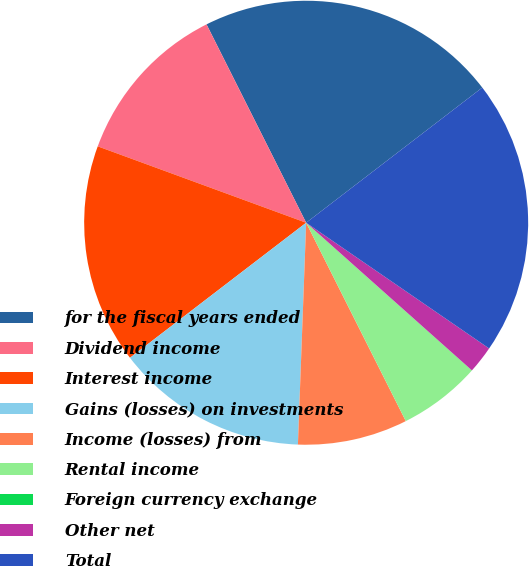Convert chart. <chart><loc_0><loc_0><loc_500><loc_500><pie_chart><fcel>for the fiscal years ended<fcel>Dividend income<fcel>Interest income<fcel>Gains (losses) on investments<fcel>Income (losses) from<fcel>Rental income<fcel>Foreign currency exchange<fcel>Other net<fcel>Total<nl><fcel>21.99%<fcel>12.0%<fcel>16.0%<fcel>14.0%<fcel>8.0%<fcel>6.0%<fcel>0.01%<fcel>2.0%<fcel>20.0%<nl></chart> 